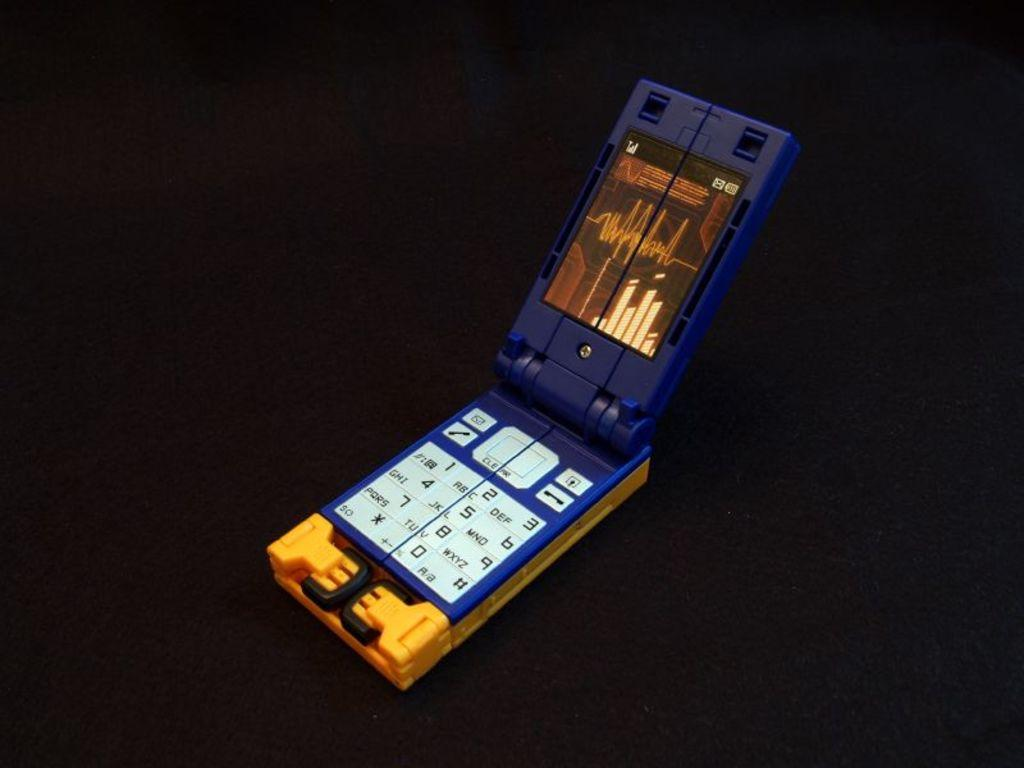<image>
Create a compact narrative representing the image presented. a cell phone is open and has the number 0 on it 